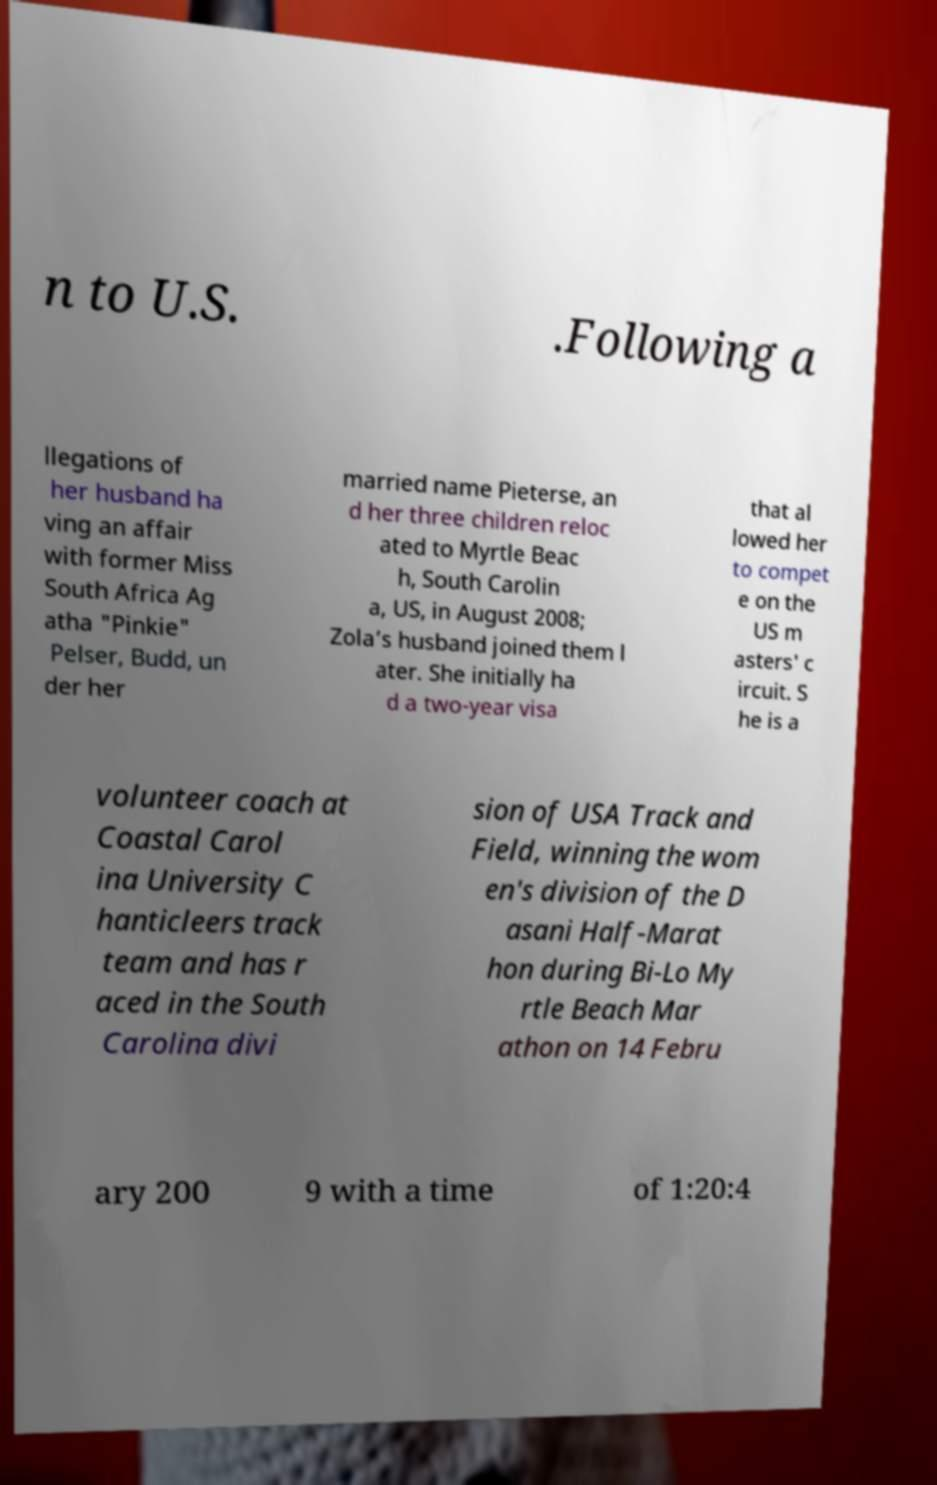Could you assist in decoding the text presented in this image and type it out clearly? n to U.S. .Following a llegations of her husband ha ving an affair with former Miss South Africa Ag atha "Pinkie" Pelser, Budd, un der her married name Pieterse, an d her three children reloc ated to Myrtle Beac h, South Carolin a, US, in August 2008; Zola’s husband joined them l ater. She initially ha d a two-year visa that al lowed her to compet e on the US m asters' c ircuit. S he is a volunteer coach at Coastal Carol ina University C hanticleers track team and has r aced in the South Carolina divi sion of USA Track and Field, winning the wom en's division of the D asani Half-Marat hon during Bi-Lo My rtle Beach Mar athon on 14 Febru ary 200 9 with a time of 1:20:4 